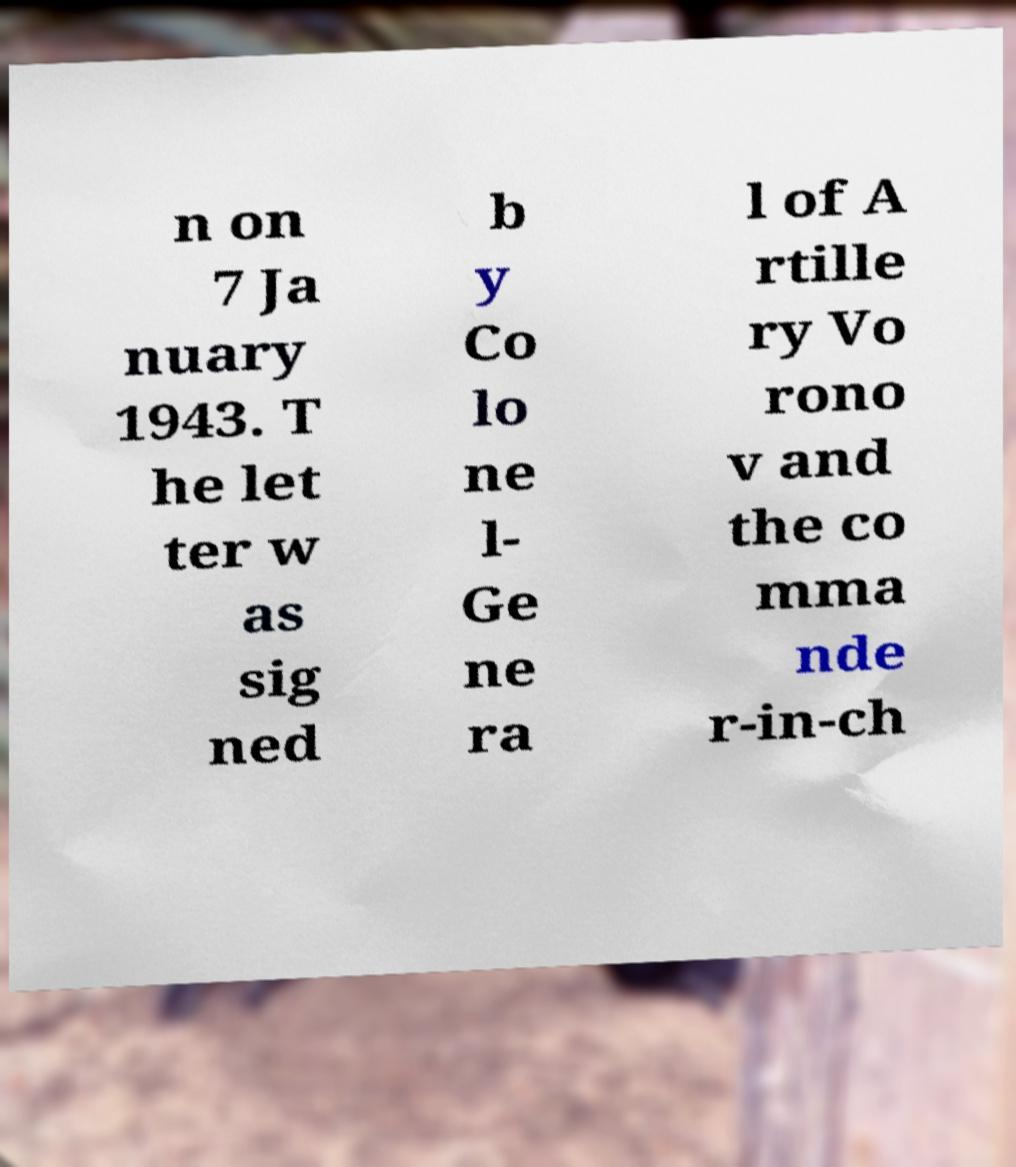Can you read and provide the text displayed in the image?This photo seems to have some interesting text. Can you extract and type it out for me? n on 7 Ja nuary 1943. T he let ter w as sig ned b y Co lo ne l- Ge ne ra l of A rtille ry Vo rono v and the co mma nde r-in-ch 